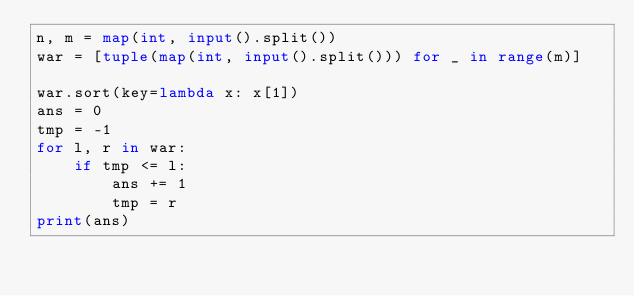<code> <loc_0><loc_0><loc_500><loc_500><_Python_>n, m = map(int, input().split())
war = [tuple(map(int, input().split())) for _ in range(m)]

war.sort(key=lambda x: x[1])
ans = 0
tmp = -1
for l, r in war:
    if tmp <= l:
        ans += 1
        tmp = r
print(ans)</code> 